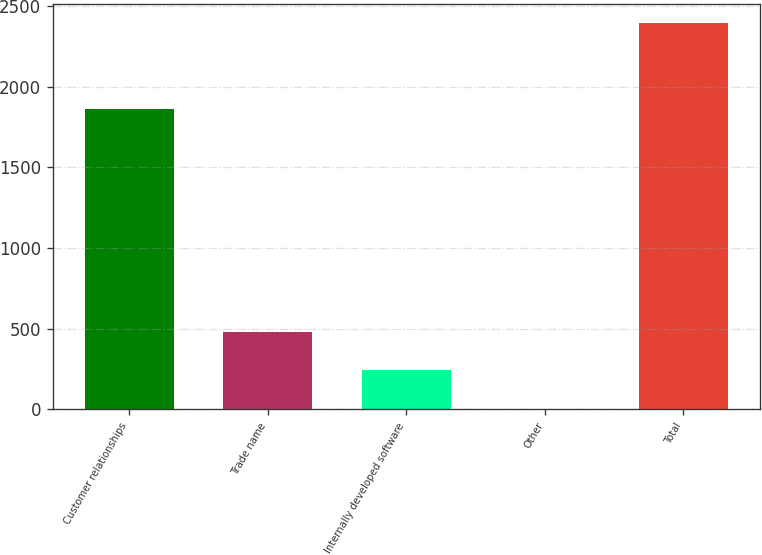Convert chart to OTSL. <chart><loc_0><loc_0><loc_500><loc_500><bar_chart><fcel>Customer relationships<fcel>Trade name<fcel>Internally developed software<fcel>Other<fcel>Total<nl><fcel>1859.7<fcel>481.36<fcel>242.28<fcel>3.2<fcel>2394<nl></chart> 